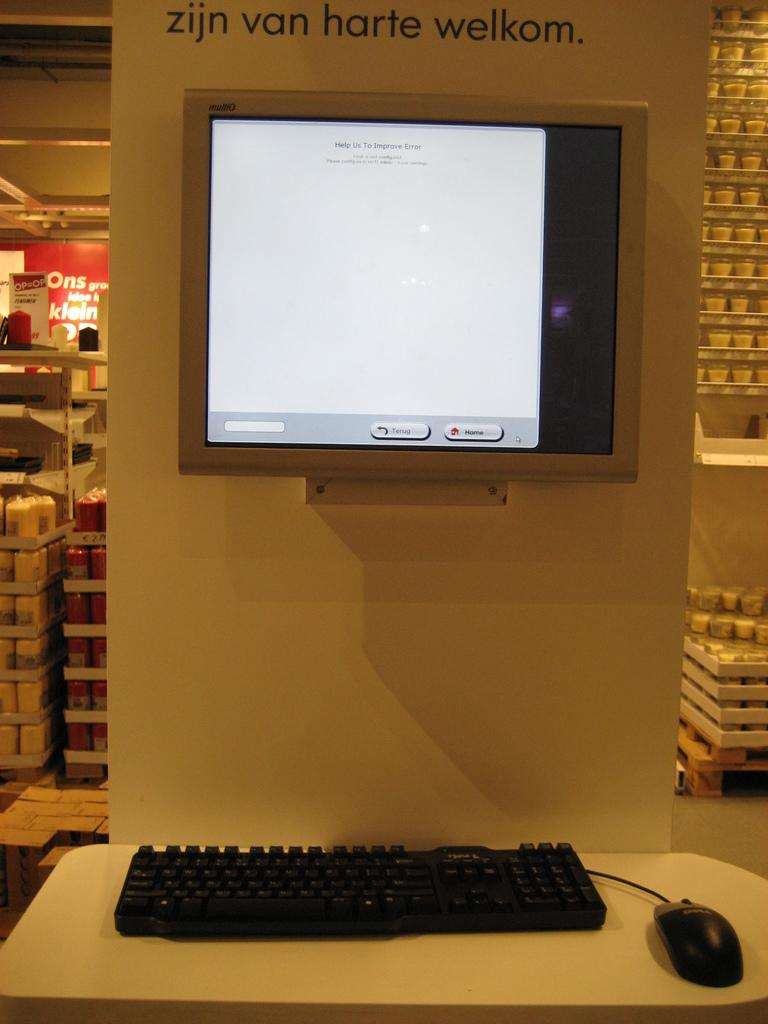Provide a one-sentence caption for the provided image. a screen on a wall that's underneath a label that says 'zijn van harte welkom'. 